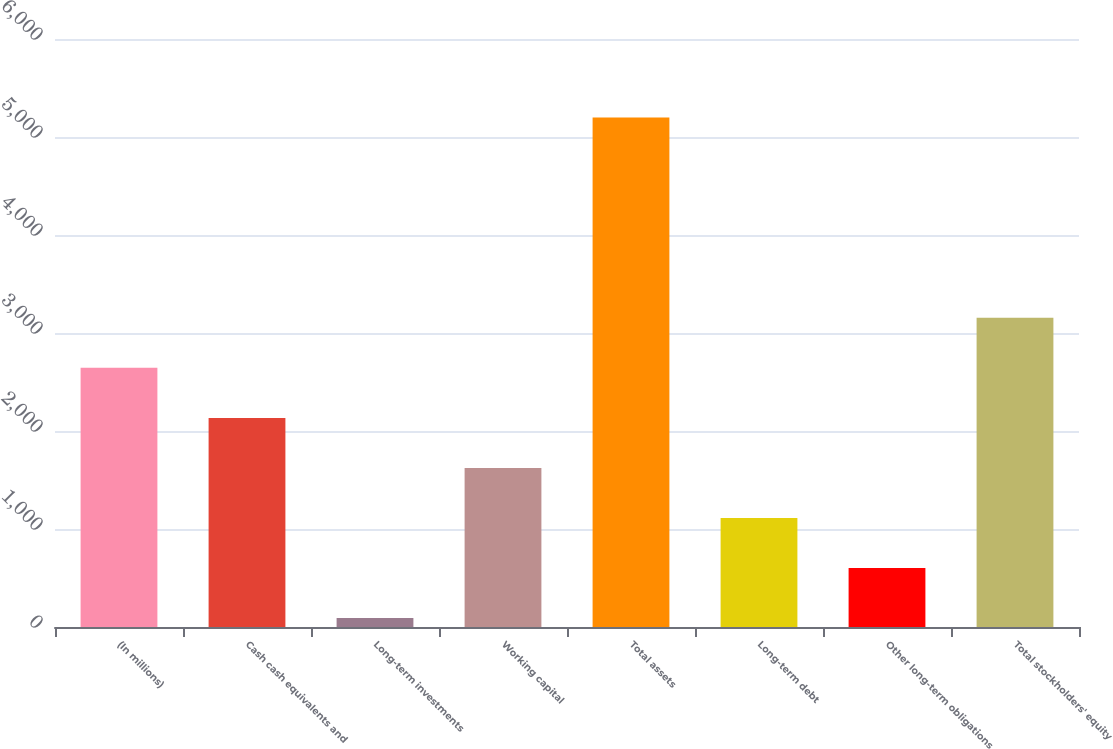Convert chart. <chart><loc_0><loc_0><loc_500><loc_500><bar_chart><fcel>(In millions)<fcel>Cash cash equivalents and<fcel>Long-term investments<fcel>Working capital<fcel>Total assets<fcel>Long-term debt<fcel>Other long-term obligations<fcel>Total stockholders' equity<nl><fcel>2644.5<fcel>2133.8<fcel>91<fcel>1623.1<fcel>5198<fcel>1112.4<fcel>601.7<fcel>3155.2<nl></chart> 